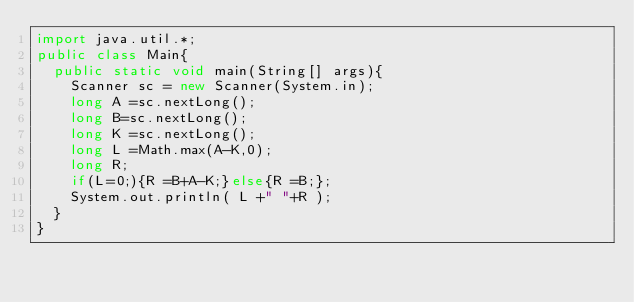<code> <loc_0><loc_0><loc_500><loc_500><_Java_>import java.util.*;
public class Main{
  public static void main(String[] args){
    Scanner sc = new Scanner(System.in);
    long A =sc.nextLong();
    long B=sc.nextLong();
    long K =sc.nextLong();
    long L =Math.max(A-K,0);
    long R;
    if(L=0;){R =B+A-K;}else{R =B;};
    System.out.println( L +" "+R );
  }
}</code> 